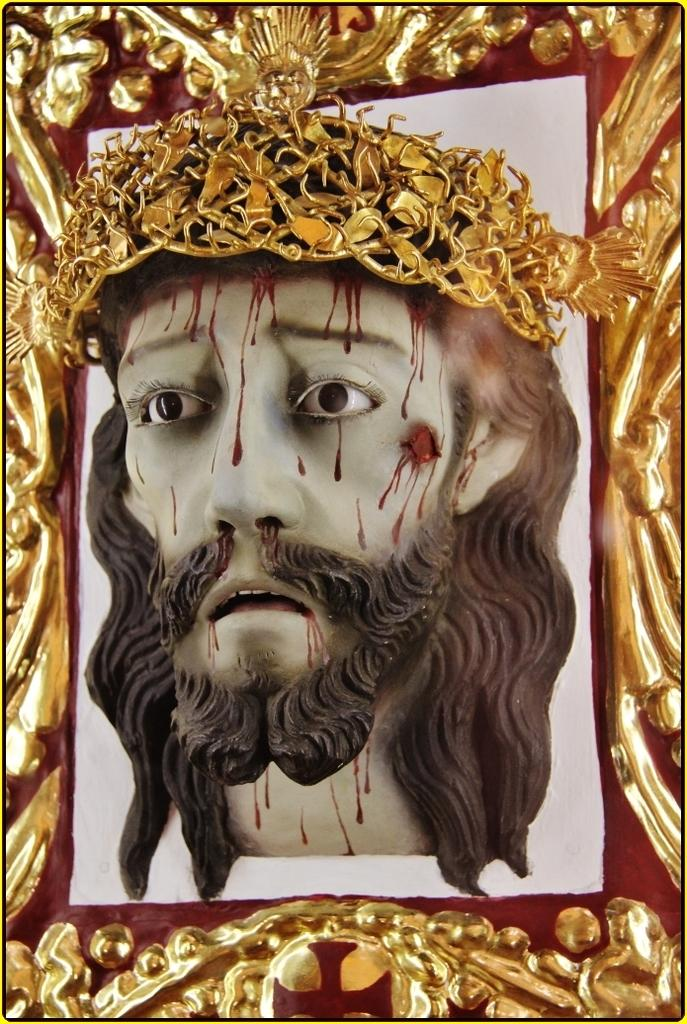What is the main subject of the image? The main subject of the image is a statue. Can you describe the statue in more detail? The statue is of a person's head, and it has a crown. How is the statue displayed in the image? The statue is in a frame. What type of dinner is being served in the image? There is no dinner or any food present in the image; it features a statue of a person's head with a crown in a frame. What activity is the servant performing in the image? There is no servant or any person performing an activity in the image; it only shows a statue in a frame. 